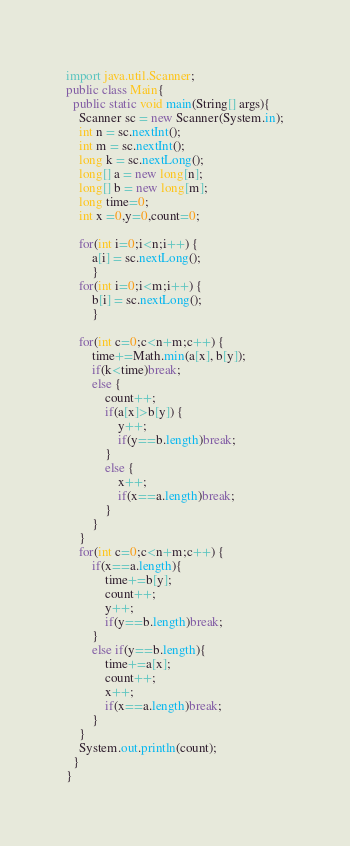Convert code to text. <code><loc_0><loc_0><loc_500><loc_500><_Java_>import java.util.Scanner;
public class Main{
  public static void main(String[] args){
    Scanner sc = new Scanner(System.in);
    int n = sc.nextInt();
    int m = sc.nextInt();
    long k = sc.nextLong();
    long[] a = new long[n];
    long[] b = new long[m];
    long time=0;
    int x =0,y=0,count=0;

    for(int i=0;i<n;i++) {
    	a[i] = sc.nextLong();
    	}
    for(int i=0;i<m;i++) {
    	b[i] = sc.nextLong();
    	}

    for(int c=0;c<n+m;c++) {
    	time+=Math.min(a[x], b[y]);
    	if(k<time)break;
    	else {
    		count++;
    		if(a[x]>b[y]) {
    			y++;
    			if(y==b.length)break;
    		}
    		else {
    			x++;
    			if(x==a.length)break;
    		}
    	}
    }
    for(int c=0;c<n+m;c++) {
    	if(x==a.length){
    		time+=b[y];
    		count++;
    		y++;
    		if(y==b.length)break;
    	}
    	else if(y==b.length){
    		time+=a[x];
    		count++;
			x++;
			if(x==a.length)break;
		}
    }
    System.out.println(count);
  }
}</code> 